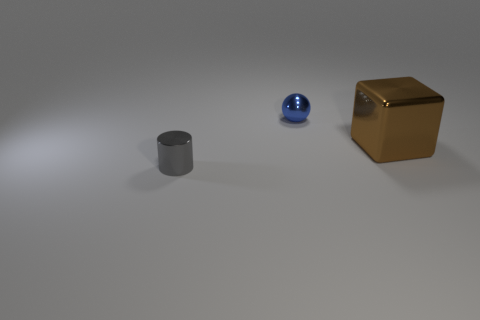Add 3 small metal objects. How many objects exist? 6 Subtract all cylinders. How many objects are left? 2 Subtract 0 blue blocks. How many objects are left? 3 Subtract all blue balls. Subtract all tiny shiny cylinders. How many objects are left? 1 Add 1 tiny gray metal cylinders. How many tiny gray metal cylinders are left? 2 Add 1 gray objects. How many gray objects exist? 2 